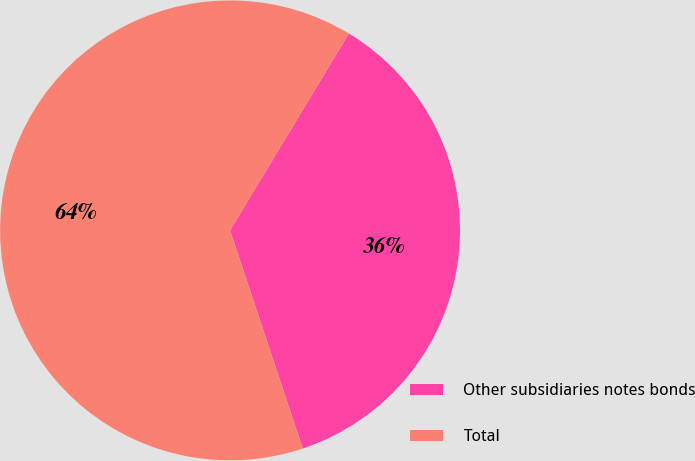<chart> <loc_0><loc_0><loc_500><loc_500><pie_chart><fcel>Other subsidiaries notes bonds<fcel>Total<nl><fcel>36.24%<fcel>63.76%<nl></chart> 